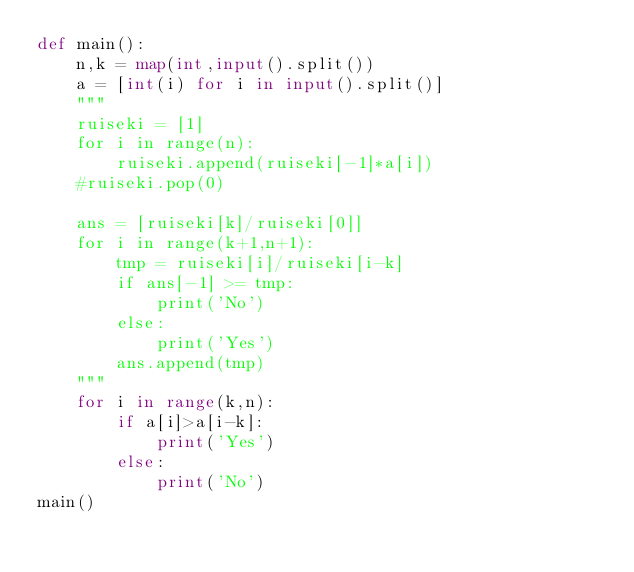<code> <loc_0><loc_0><loc_500><loc_500><_Python_>def main():
    n,k = map(int,input().split())
    a = [int(i) for i in input().split()]
    """
    ruiseki = [1]
    for i in range(n):
        ruiseki.append(ruiseki[-1]*a[i])
    #ruiseki.pop(0)
    
    ans = [ruiseki[k]/ruiseki[0]]
    for i in range(k+1,n+1):
        tmp = ruiseki[i]/ruiseki[i-k]
        if ans[-1] >= tmp:
            print('No')
        else:
            print('Yes')
        ans.append(tmp)
    """
    for i in range(k,n):
        if a[i]>a[i-k]:
            print('Yes')
        else:
            print('No')
main()</code> 